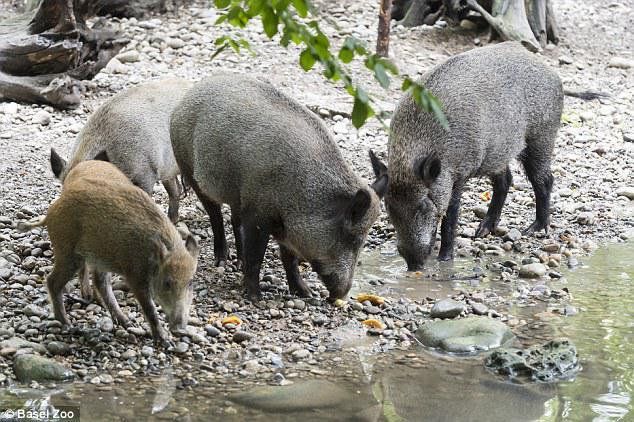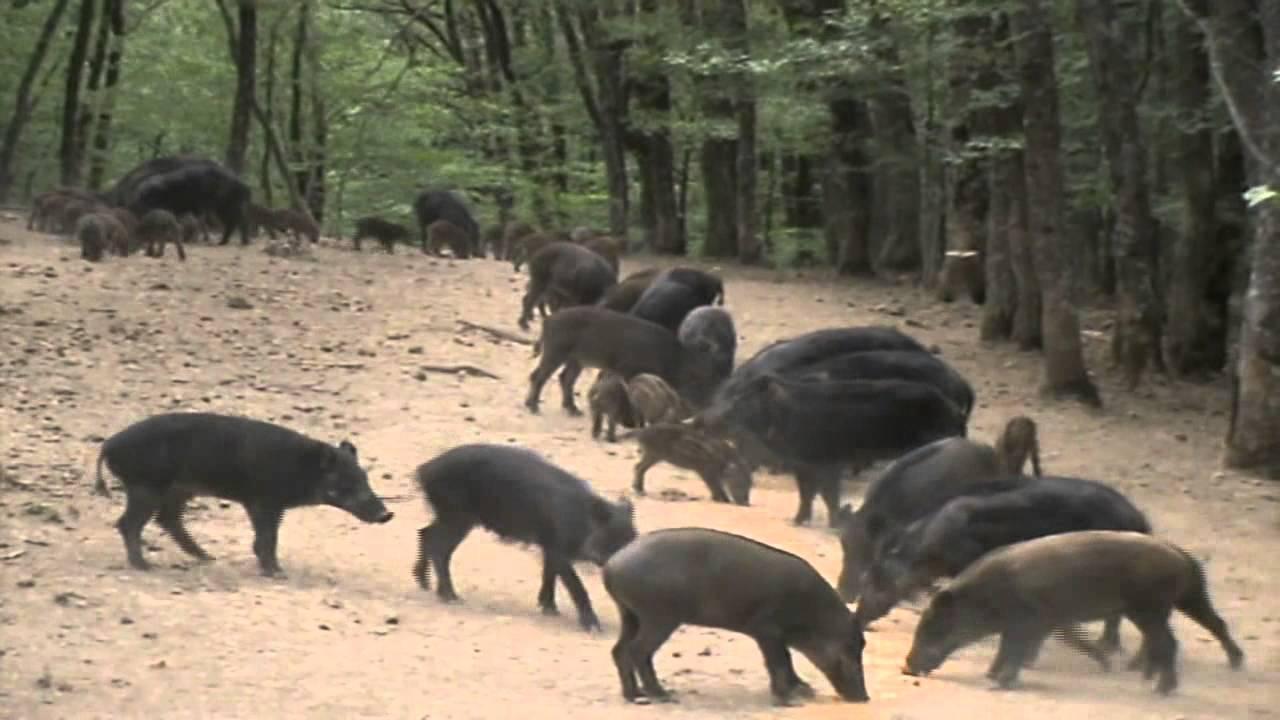The first image is the image on the left, the second image is the image on the right. Considering the images on both sides, is "One of the images shows only 4 animals." valid? Answer yes or no. Yes. The first image is the image on the left, the second image is the image on the right. Assess this claim about the two images: "One image contains no more than 4 pigs.". Correct or not? Answer yes or no. Yes. 